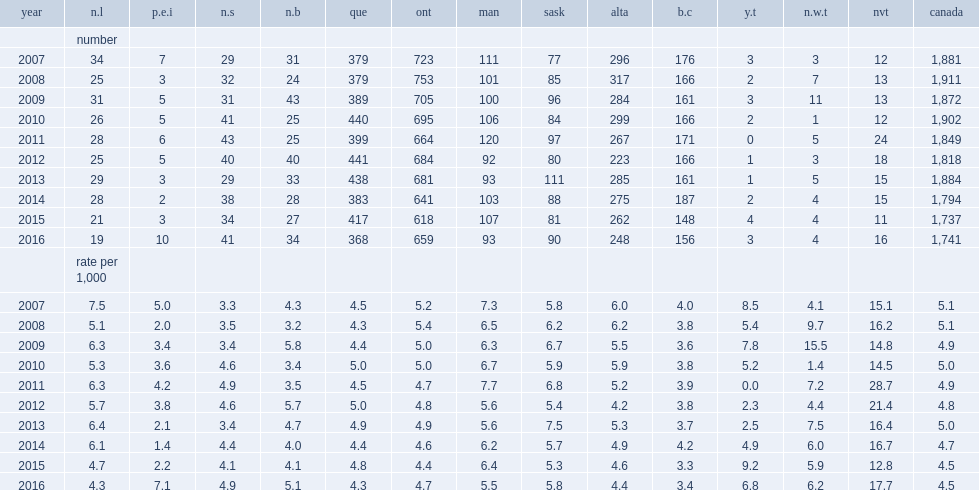In which province or territory is the lowest rate in 2016? B.c. In which province or territory is the highest rate in 2016? Nvt. In which provinces have the highest infant mortality rates been over the last 10 years? Man sask. 